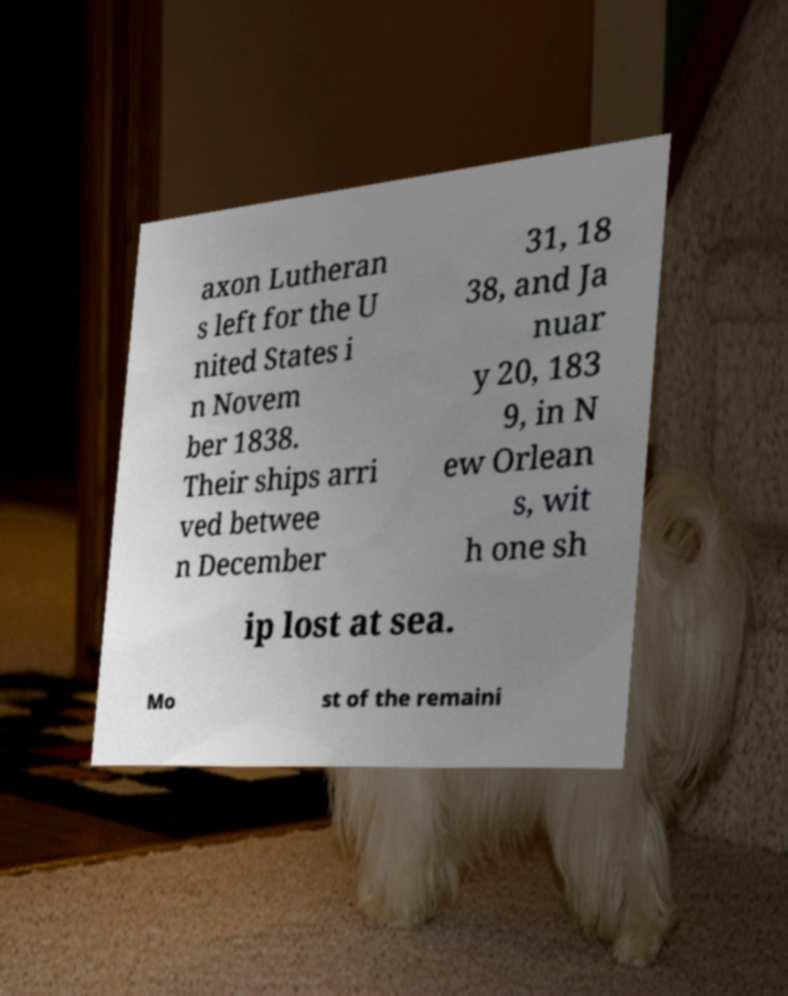Could you assist in decoding the text presented in this image and type it out clearly? axon Lutheran s left for the U nited States i n Novem ber 1838. Their ships arri ved betwee n December 31, 18 38, and Ja nuar y 20, 183 9, in N ew Orlean s, wit h one sh ip lost at sea. Mo st of the remaini 